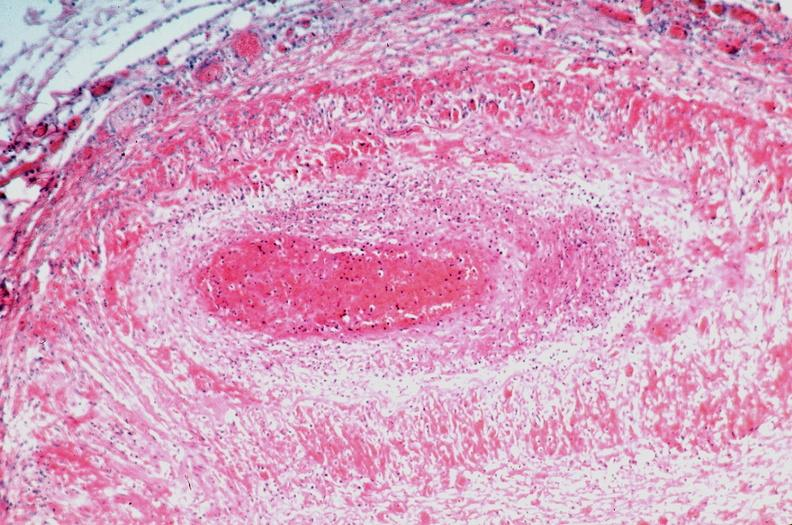s vessel present?
Answer the question using a single word or phrase. No 